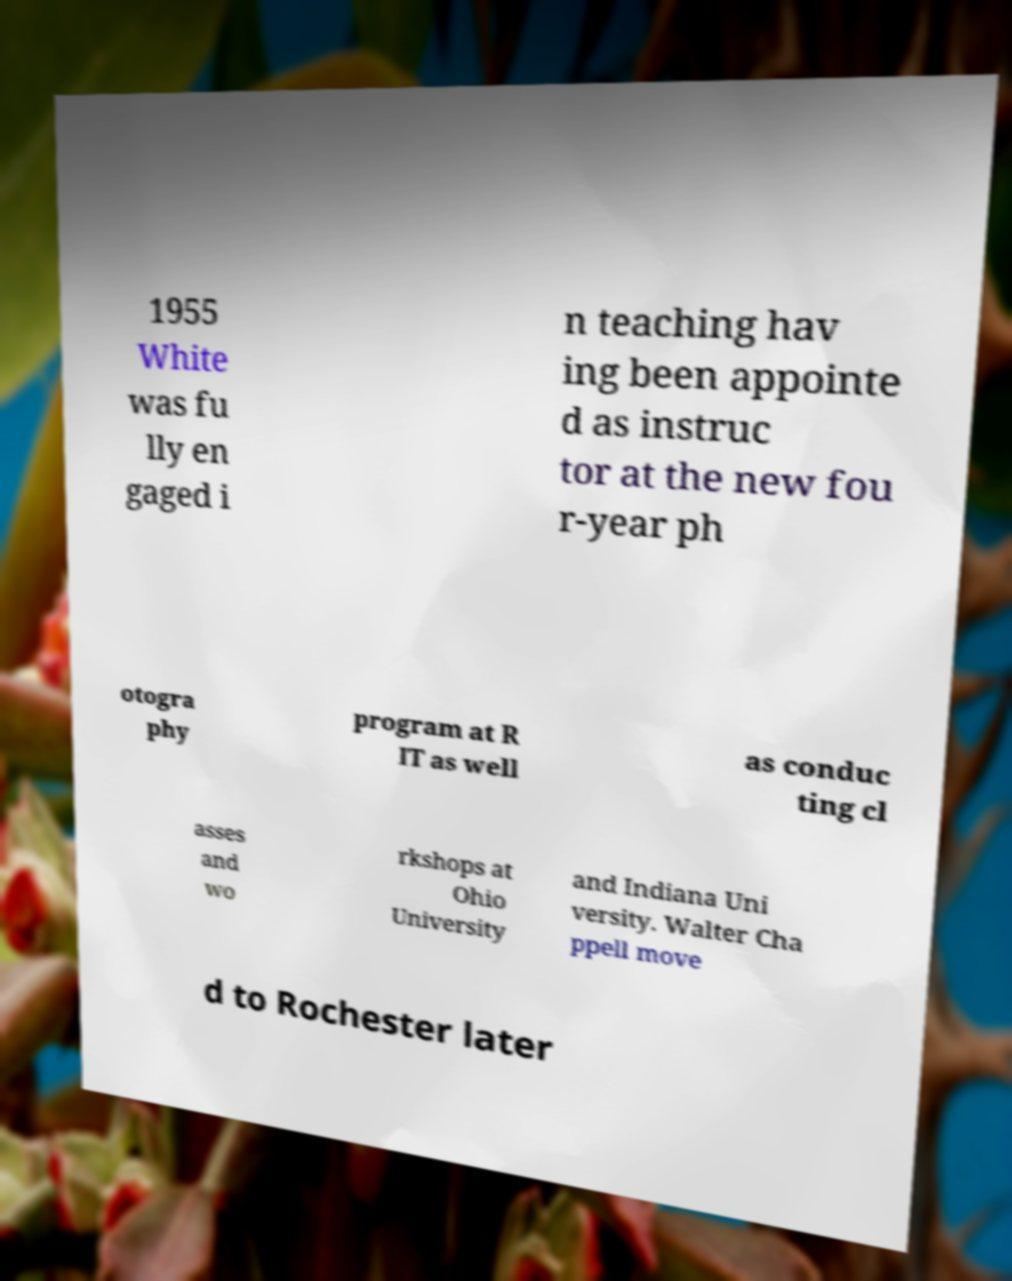Can you accurately transcribe the text from the provided image for me? 1955 White was fu lly en gaged i n teaching hav ing been appointe d as instruc tor at the new fou r-year ph otogra phy program at R IT as well as conduc ting cl asses and wo rkshops at Ohio University and Indiana Uni versity. Walter Cha ppell move d to Rochester later 